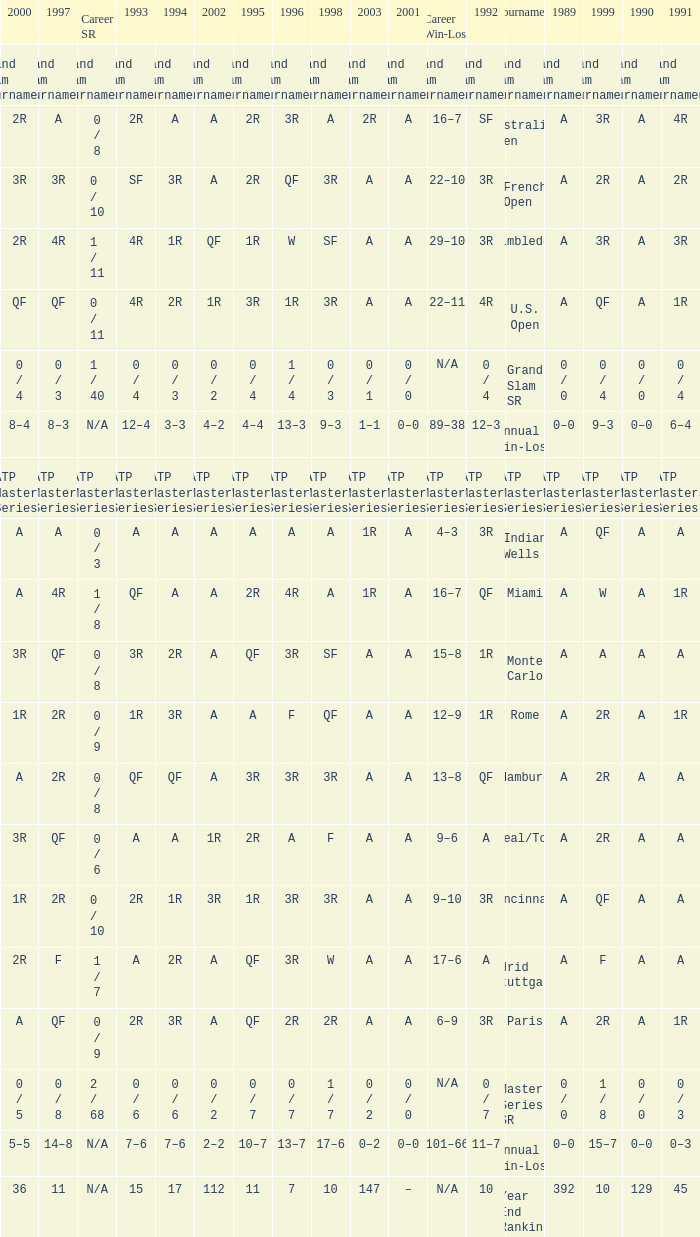What was the career SR with a value of A in 1980 and F in 1997? 1 / 7. 